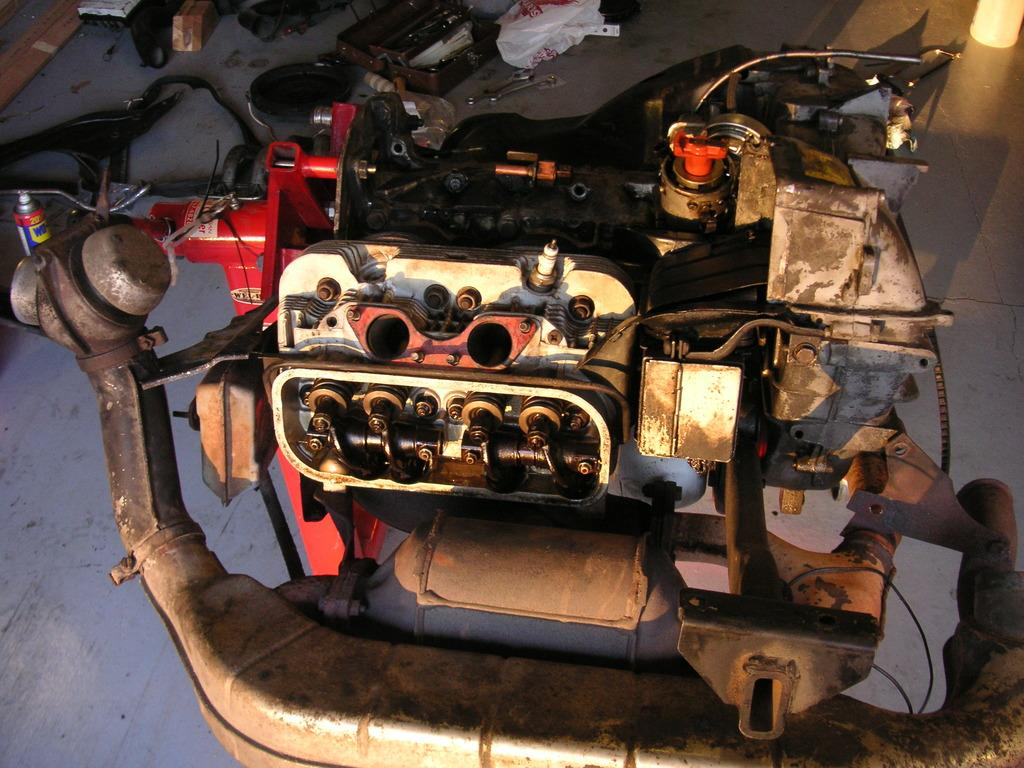What type of objects can be seen in the image? There are machines in the image. Are there any other objects on the floor in the image? Yes, there are other objects on the floor in the image. What type of drug is being used in the jail in the image? There is no jail or drug present in the image; it only features machines and other objects on the floor. 